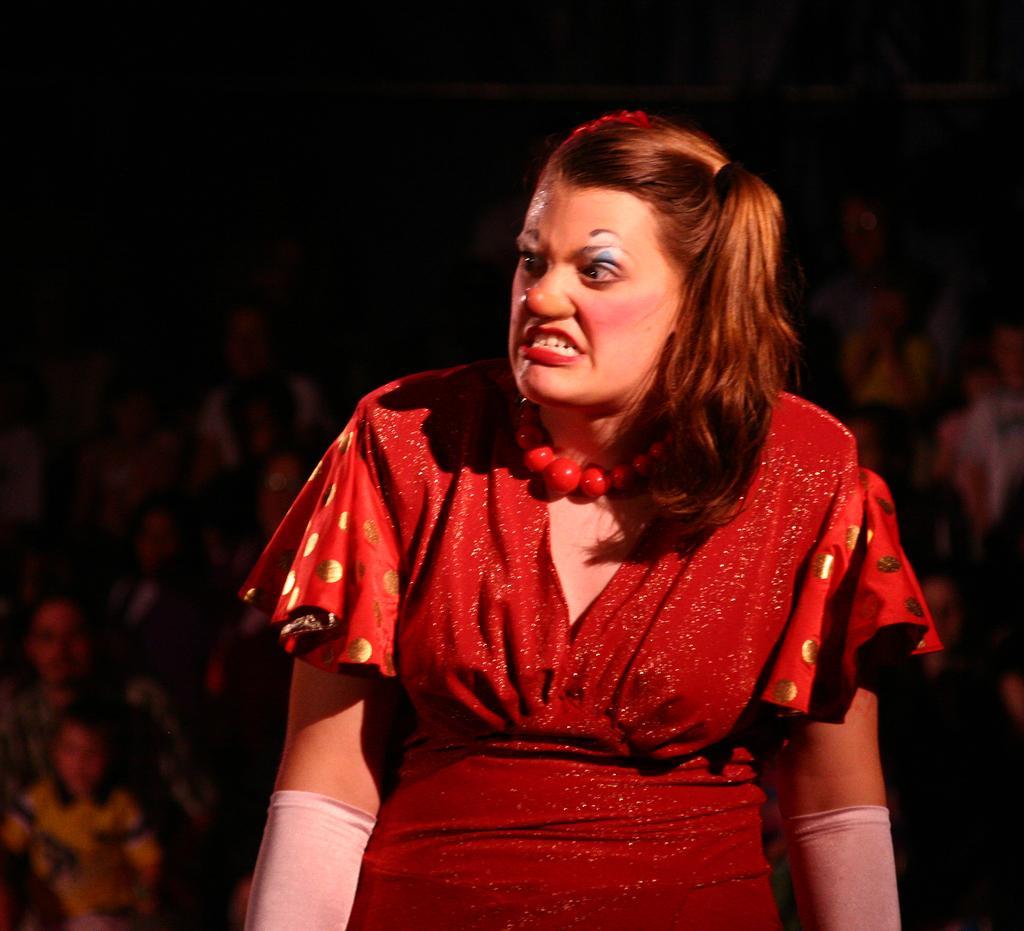Describe this image in one or two sentences. In this image we can see a woman. On the backside we can see a group of people sitting. 